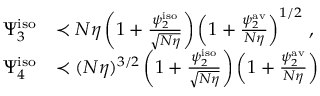Convert formula to latex. <formula><loc_0><loc_0><loc_500><loc_500>\begin{array} { r l } { \Psi _ { 3 } ^ { i s o } } & { \prec N \eta \left ( 1 + \frac { \psi _ { 2 } ^ { i s o } } { \sqrt { N \eta } } \right ) \left ( 1 + \frac { \psi _ { 2 } ^ { a v } } { N \eta } \right ) ^ { 1 / 2 } \, , } \\ { \Psi _ { 4 } ^ { i s o } } & { \prec ( N \eta ) ^ { 3 / 2 } \left ( 1 + \frac { \psi _ { 2 } ^ { i s o } } { \sqrt { N \eta } } \right ) \left ( 1 + \frac { \psi _ { 2 } ^ { a v } } { N \eta } \right ) \, } \end{array}</formula> 